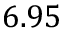Convert formula to latex. <formula><loc_0><loc_0><loc_500><loc_500>6 . 9 5</formula> 